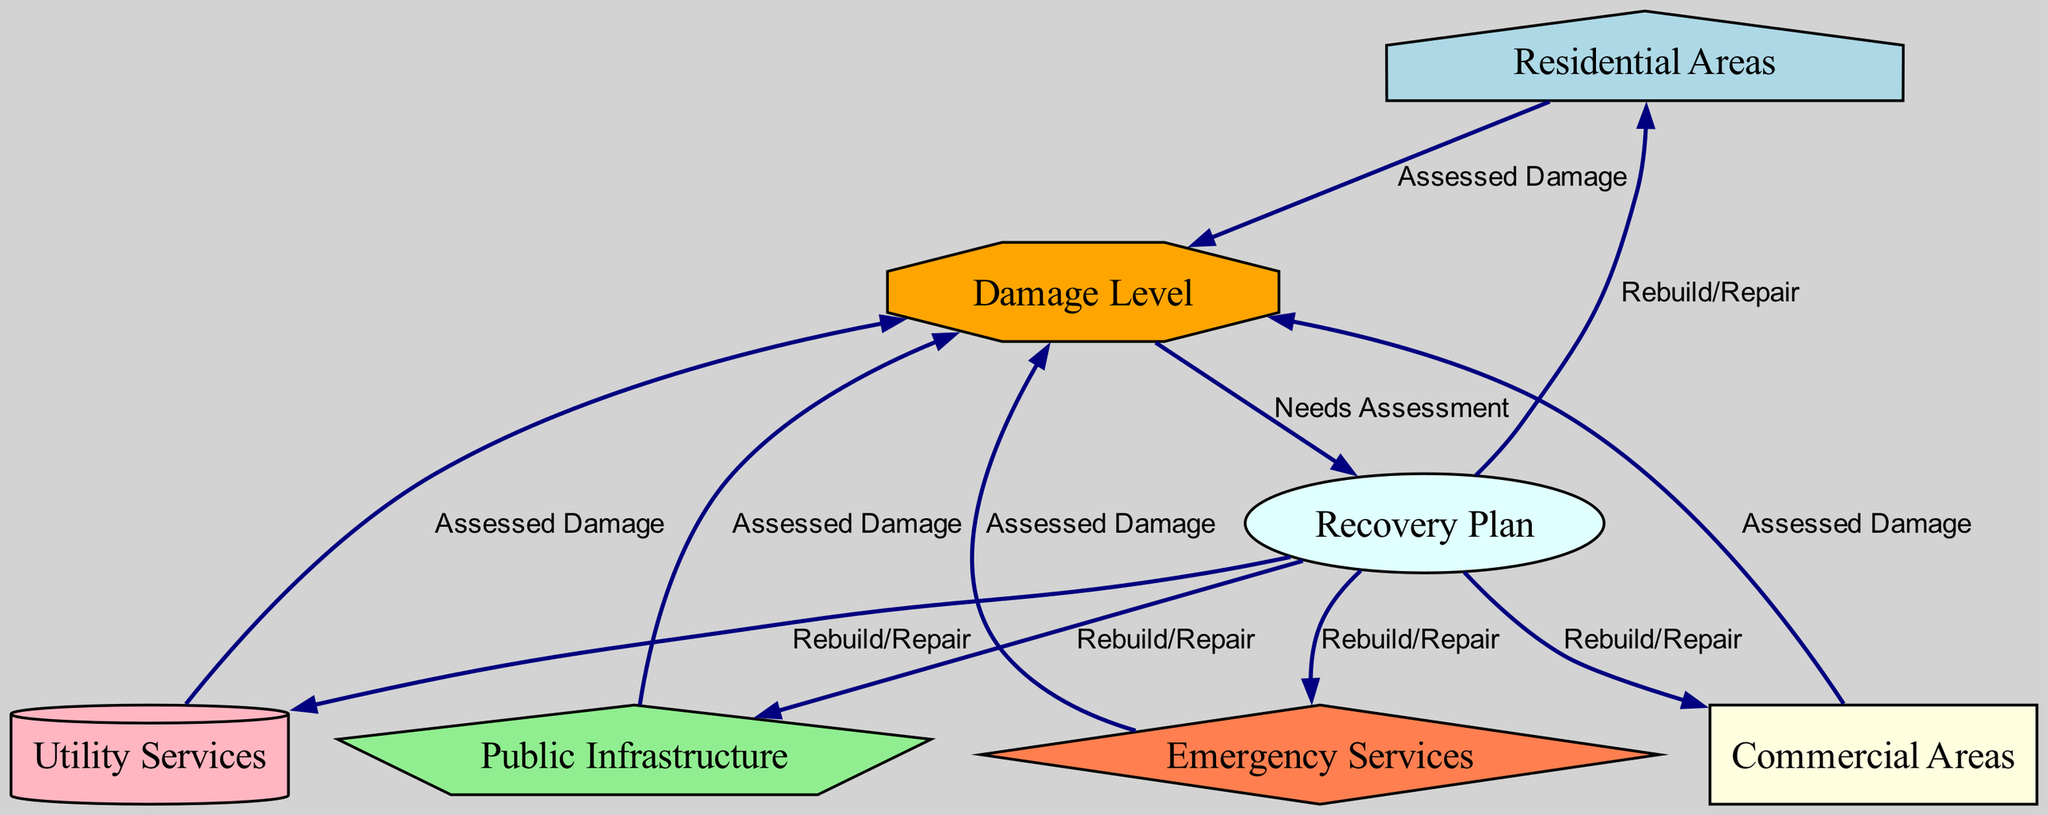What are the key areas impacted by the hurricane? The diagram lists five key areas affected: Residential Areas, Commercial Areas, Public Infrastructure, Utility Services, and Emergency Services. These are represented as nodes in the diagram.
Answer: Residential Areas, Commercial Areas, Public Infrastructure, Utility Services, Emergency Services How many nodes are there in the diagram? By counting the nodes presented, we find that there are a total of seven distinct nodes: five area types, one damage level, and one recovery plan.
Answer: 7 What is the shape representing damage level? The damage level node is represented by an octagon shape in the diagram, which is indicated as a distinct visual representation.
Answer: Octagon What is the relationship between 'public infrastructure' and 'damage level'? The relation is indicated by a directed edge labeled "Assessed Damage," showing that the public infrastructure's damage level is assessed post-hurricane.
Answer: Assessed Damage Which areas are included in the recovery plan? The recovery plan addresses five specific areas: Residential Areas, Commercial Areas, Public Infrastructure, Utility Services, and Emergency Services, as indicated by the edges pointing from the recovery plan node to these areas.
Answer: Residential Areas, Commercial Areas, Public Infrastructure, Utility Services, Emergency Services What determines the steps in the recovery plan? The steps in the recovery plan are determined by the needs assessment related to the damage level of the areas affected. The recovery plan node is directly connected to the damage level node, highlighting this relationship.
Answer: Needs Assessment Which area is linked to the highest assessed damage? The diagram does not specify which area has the highest damage; it merely indicates that each area’s damage is assessed, implying all areas are evaluated, but does not rank them.
Answer: All Areas Assessed What are the steps after the needs assessment? After the needs assessment, the recovery plan directs actions to rebuild or repair each affected area, according to the edges indicating the flow from recovery plan to each area node.
Answer: Rebuild/Repair 